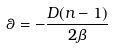Convert formula to latex. <formula><loc_0><loc_0><loc_500><loc_500>\theta = - \frac { D ( n - 1 ) } { 2 \beta }</formula> 